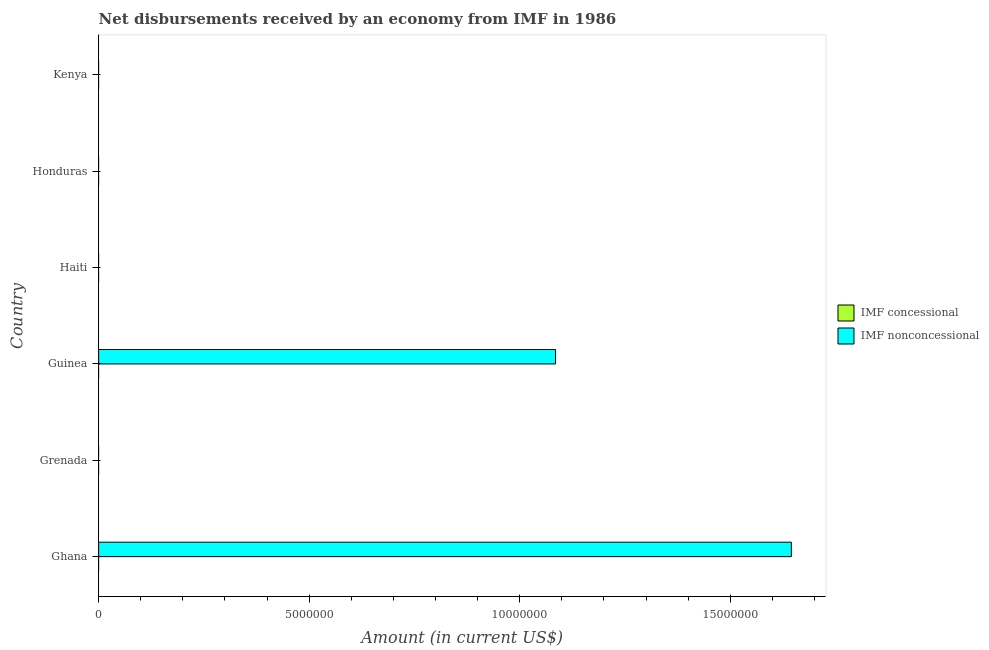How many different coloured bars are there?
Ensure brevity in your answer.  1. Are the number of bars on each tick of the Y-axis equal?
Keep it short and to the point. No. How many bars are there on the 2nd tick from the top?
Offer a very short reply. 0. What is the label of the 4th group of bars from the top?
Offer a very short reply. Guinea. What is the net non concessional disbursements from imf in Guinea?
Provide a succinct answer. 1.08e+07. Across all countries, what is the maximum net non concessional disbursements from imf?
Your answer should be very brief. 1.64e+07. Across all countries, what is the minimum net concessional disbursements from imf?
Provide a short and direct response. 0. In which country was the net non concessional disbursements from imf maximum?
Ensure brevity in your answer.  Ghana. What is the difference between the net non concessional disbursements from imf in Ghana and the net concessional disbursements from imf in Honduras?
Give a very brief answer. 1.64e+07. What is the average net concessional disbursements from imf per country?
Make the answer very short. 0. What is the difference between the highest and the lowest net non concessional disbursements from imf?
Your answer should be compact. 1.64e+07. In how many countries, is the net non concessional disbursements from imf greater than the average net non concessional disbursements from imf taken over all countries?
Ensure brevity in your answer.  2. How many bars are there?
Offer a very short reply. 2. Are all the bars in the graph horizontal?
Your answer should be very brief. Yes. What is the difference between two consecutive major ticks on the X-axis?
Offer a very short reply. 5.00e+06. Are the values on the major ticks of X-axis written in scientific E-notation?
Make the answer very short. No. Does the graph contain any zero values?
Your response must be concise. Yes. Where does the legend appear in the graph?
Offer a very short reply. Center right. How are the legend labels stacked?
Keep it short and to the point. Vertical. What is the title of the graph?
Your answer should be very brief. Net disbursements received by an economy from IMF in 1986. Does "Resident" appear as one of the legend labels in the graph?
Offer a terse response. No. What is the Amount (in current US$) in IMF nonconcessional in Ghana?
Your answer should be compact. 1.64e+07. What is the Amount (in current US$) in IMF concessional in Grenada?
Ensure brevity in your answer.  0. What is the Amount (in current US$) in IMF nonconcessional in Guinea?
Keep it short and to the point. 1.08e+07. What is the Amount (in current US$) of IMF concessional in Haiti?
Offer a very short reply. 0. What is the Amount (in current US$) of IMF nonconcessional in Haiti?
Provide a succinct answer. 0. What is the Amount (in current US$) in IMF concessional in Honduras?
Ensure brevity in your answer.  0. What is the Amount (in current US$) in IMF nonconcessional in Honduras?
Provide a short and direct response. 0. What is the Amount (in current US$) in IMF concessional in Kenya?
Give a very brief answer. 0. What is the Amount (in current US$) in IMF nonconcessional in Kenya?
Your answer should be compact. 0. Across all countries, what is the maximum Amount (in current US$) of IMF nonconcessional?
Make the answer very short. 1.64e+07. Across all countries, what is the minimum Amount (in current US$) in IMF nonconcessional?
Your answer should be compact. 0. What is the total Amount (in current US$) in IMF concessional in the graph?
Keep it short and to the point. 0. What is the total Amount (in current US$) of IMF nonconcessional in the graph?
Provide a succinct answer. 2.73e+07. What is the difference between the Amount (in current US$) in IMF nonconcessional in Ghana and that in Guinea?
Offer a very short reply. 5.60e+06. What is the average Amount (in current US$) in IMF nonconcessional per country?
Provide a short and direct response. 4.55e+06. What is the ratio of the Amount (in current US$) of IMF nonconcessional in Ghana to that in Guinea?
Your response must be concise. 1.52. What is the difference between the highest and the lowest Amount (in current US$) of IMF nonconcessional?
Ensure brevity in your answer.  1.64e+07. 